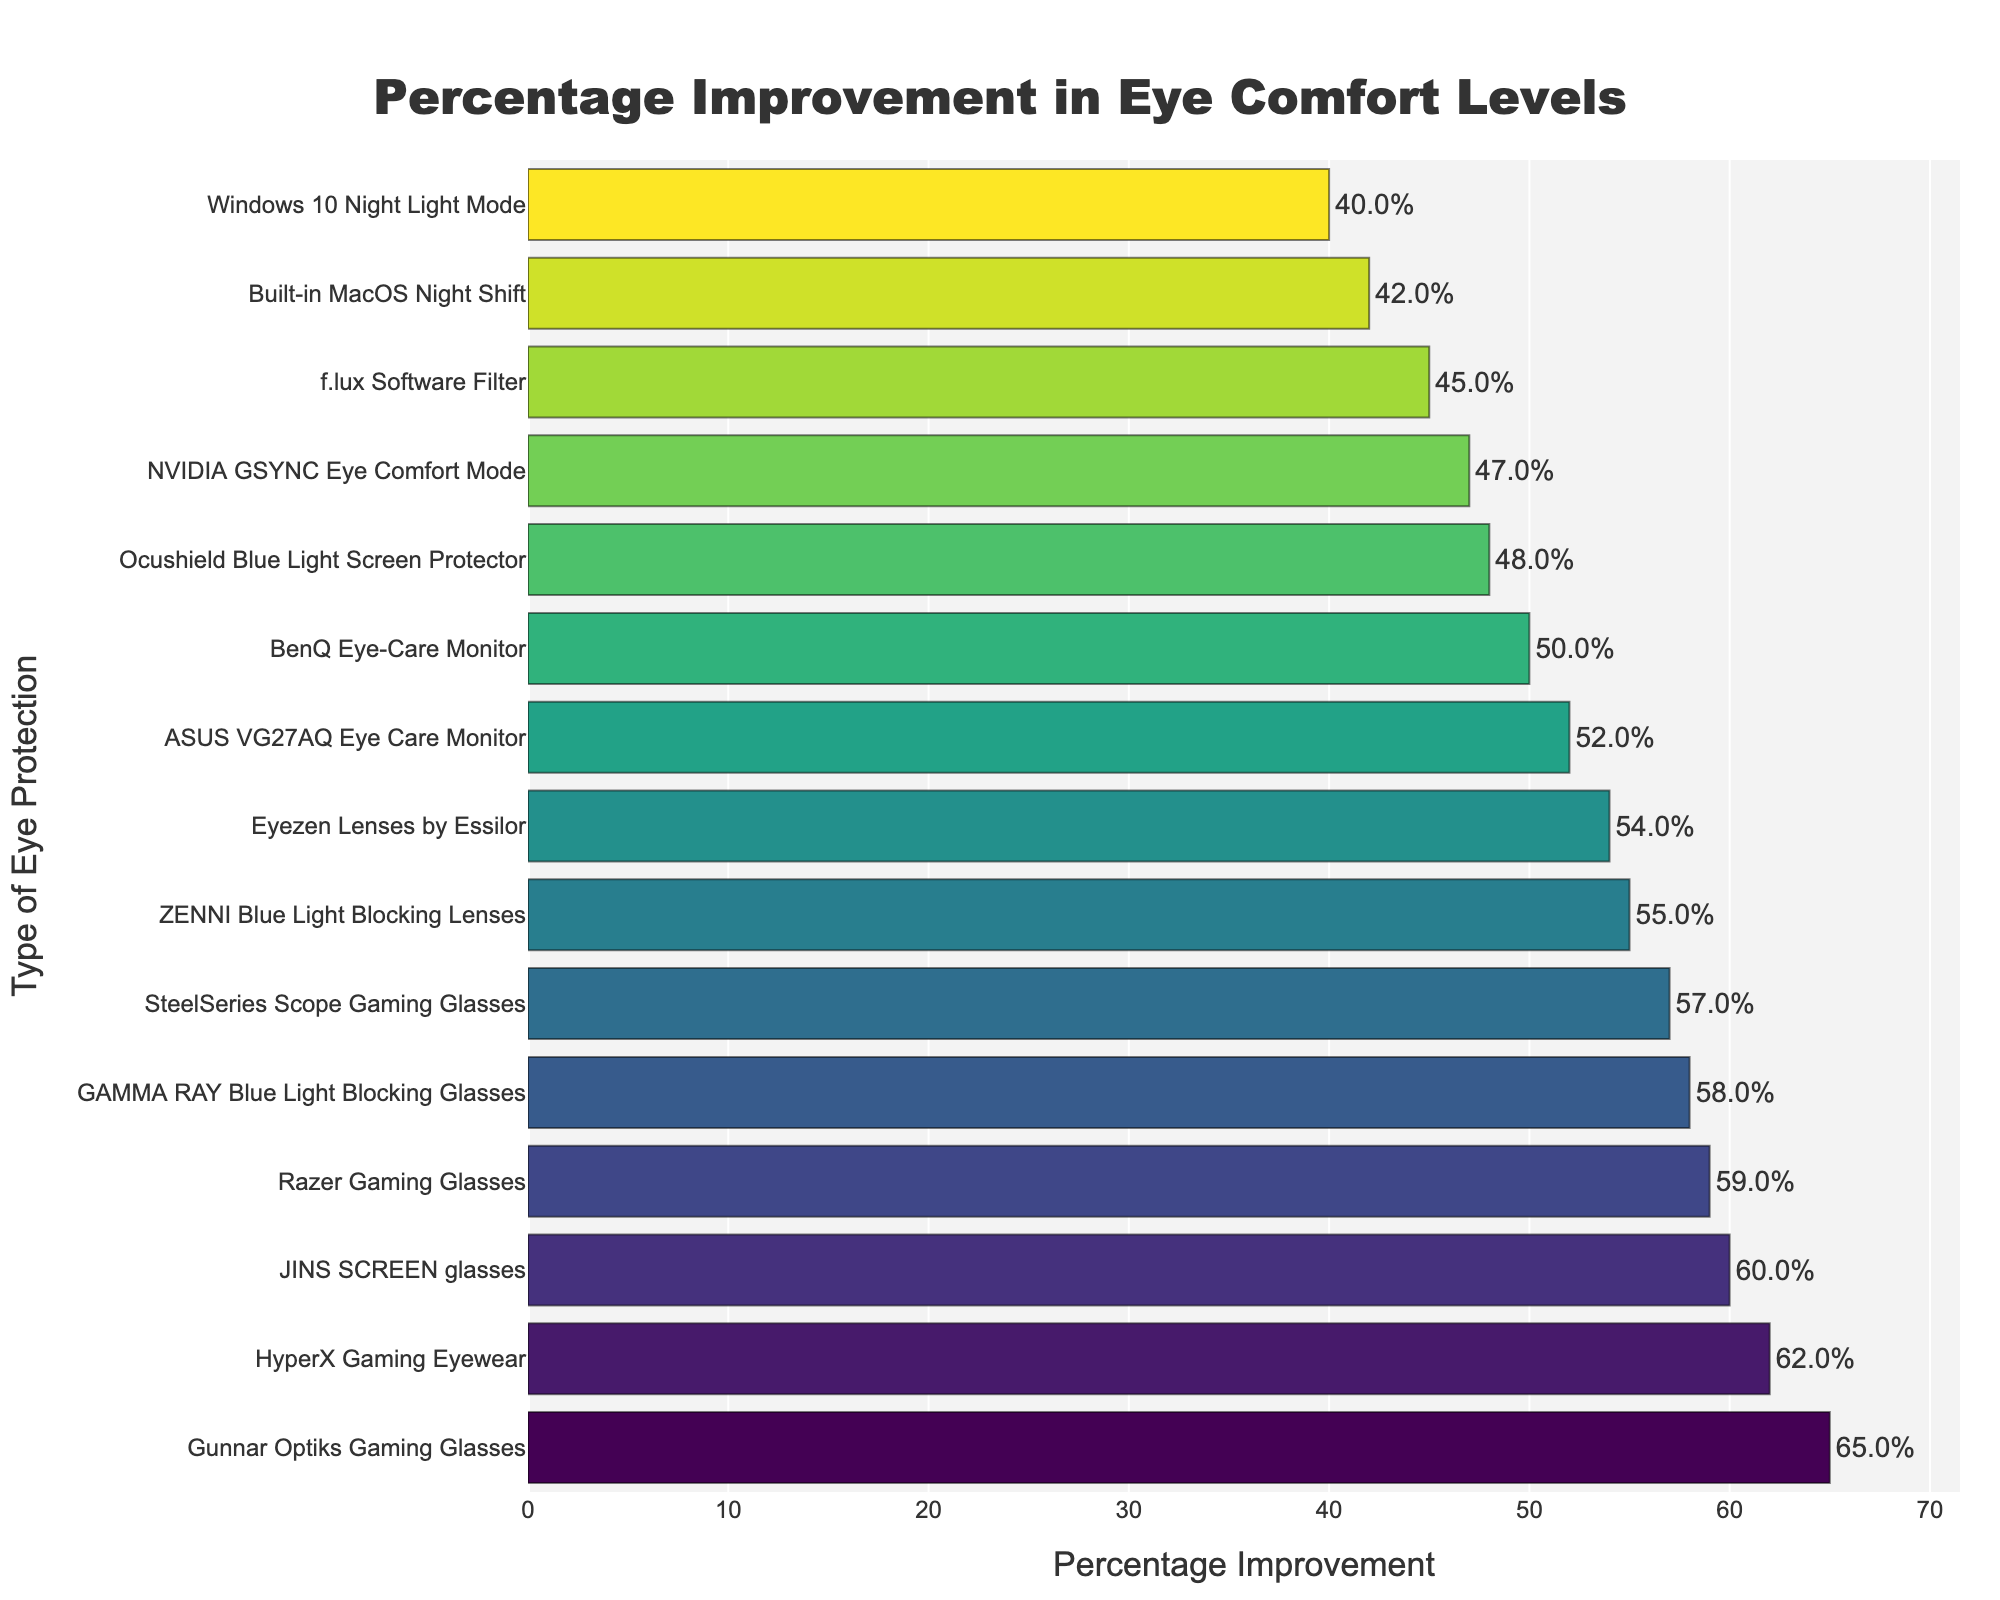What type of eye protection shows the highest percentage improvement in eye comfort levels? According to the bar chart, the Gunnar Optiks Gaming Glasses have the highest percentage improvement.
Answer: Gunnar Optiks Gaming Glasses Which type of eye protection has a lower percentage improvement: f.lux Software Filter or Built-in MacOS Night Shift? By examining the bar chart, the f.lux Software Filter has a percentage improvement of 45%, and the Built-in MacOS Night Shift has 42%. Hence, Built-in MacOS Night Shift is lower.
Answer: Built-in MacOS Night Shift How does the percentage improvement of JINS SCREEN glasses compare to BenQ Eye-Care Monitor? From the chart, JINS SCREEN glasses have a percentage improvement of 60%, whereas BenQ Eye-Care Monitor has 50%. JINS SCREEN glasses have a higher improvement.
Answer: JINS SCREEN glasses What's the average percentage improvement among the top three eye protection products? The top three products by percentage improvement are Gunnar Optiks Gaming Glasses (65%), HyperX Gaming Eyewear (62%), and JINS SCREEN glasses (60%). Their average is (65+62+60)/3 = 62.3%
Answer: 62.3% Which product has the closest percentage improvement to 50%? By looking at the chart, BenQ Eye-Care Monitor shows a percentage improvement of 50%, which is the closest to 50%.
Answer: BenQ Eye-Care Monitor How much higher is the percentage improvement of the highest protection compared to the lowest? The highest improvement is Gunnar Optiks Gaming Glasses at 65%, and the lowest is Built-in MacOS Night Shift at 42%. The difference is 65% - 42% = 23%.
Answer: 23% What is the median percentage improvement across all products? Listing the improvements in ascending order: 40, 42, 45, 47, 48, 50, 52, 54, 55, 57, 58, 59, 60, 62, 65. The median (middle value in an ordered list) is 54.
Answer: 54% Identify which eye protection types have a percentage above 55% but below 65%. From the bar chart, the products in this range are: GAMMA RAY Blue Light Blocking Glasses (58%), JINS SCREEN glasses (60%), HyperX Gaming Eyewear (62%), Razer Gaming Glasses (59%), SteelSeries Scope Gaming Glasses (57%), and Eyezen Lenses by Essilor (54%).
Answer: GAMMA RAY Blue Light Blocking Glasses, JINS SCREEN glasses, HyperX Gaming Eyewear, Razer Gaming Glasses, SteelSeries Scope Gaming Glasses, Eyezen Lenses by Essilor 